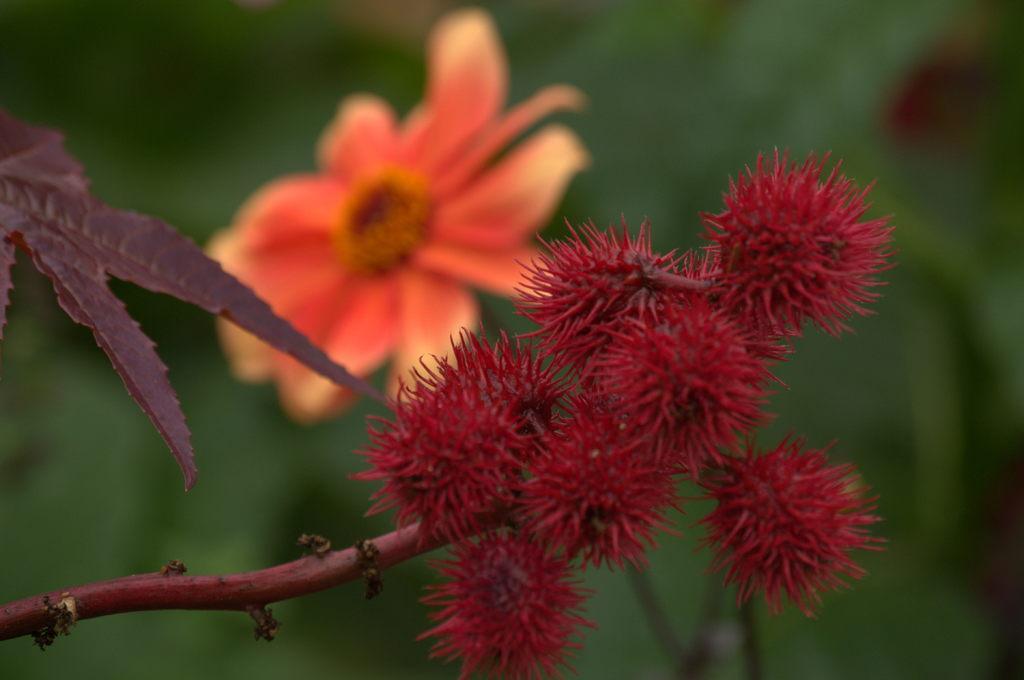Could you give a brief overview of what you see in this image? In this image I can see rambutan fruits to a stem. On the left side there is a leaf. In the background there is a flower. The background is blurred. 